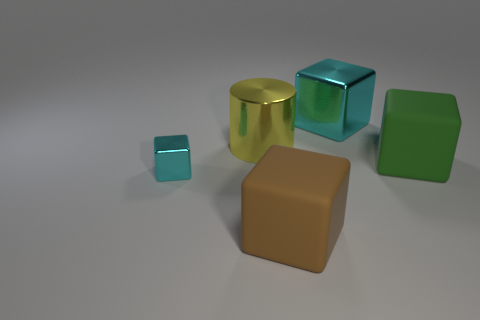What materials do these objects appear to be made of? The objects in the image seem to have a reflective surface, suggesting they might be made of a polished metal or a glossy plastic with metallic paint. 